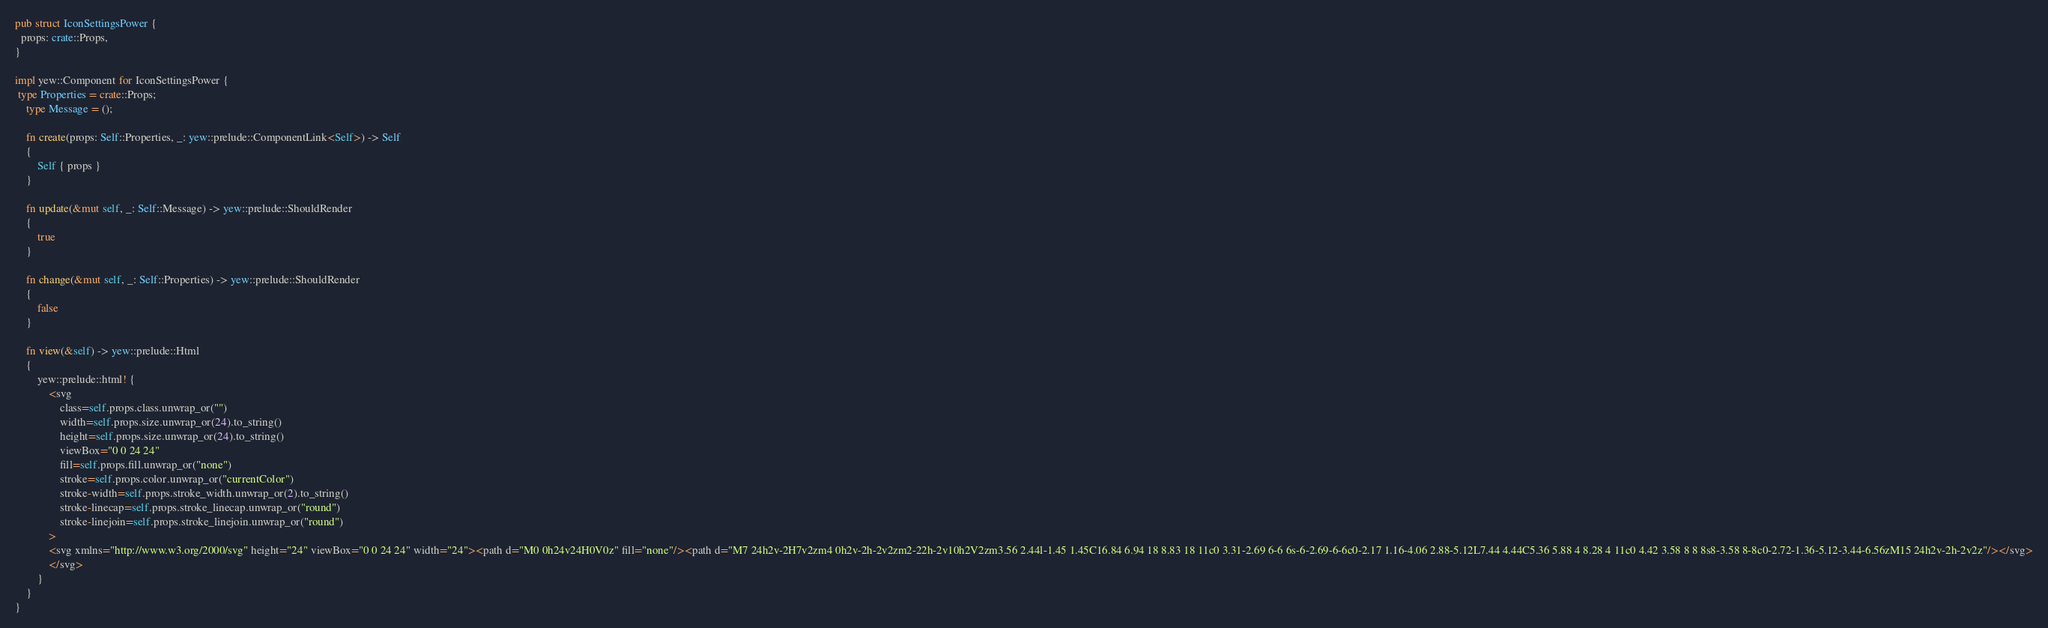<code> <loc_0><loc_0><loc_500><loc_500><_Rust_>
pub struct IconSettingsPower {
  props: crate::Props,
}

impl yew::Component for IconSettingsPower {
 type Properties = crate::Props;
    type Message = ();

    fn create(props: Self::Properties, _: yew::prelude::ComponentLink<Self>) -> Self
    {
        Self { props }
    }

    fn update(&mut self, _: Self::Message) -> yew::prelude::ShouldRender
    {
        true
    }

    fn change(&mut self, _: Self::Properties) -> yew::prelude::ShouldRender
    {
        false
    }

    fn view(&self) -> yew::prelude::Html
    {
        yew::prelude::html! {
            <svg
                class=self.props.class.unwrap_or("")
                width=self.props.size.unwrap_or(24).to_string()
                height=self.props.size.unwrap_or(24).to_string()
                viewBox="0 0 24 24"
                fill=self.props.fill.unwrap_or("none")
                stroke=self.props.color.unwrap_or("currentColor")
                stroke-width=self.props.stroke_width.unwrap_or(2).to_string()
                stroke-linecap=self.props.stroke_linecap.unwrap_or("round")
                stroke-linejoin=self.props.stroke_linejoin.unwrap_or("round")
            >
            <svg xmlns="http://www.w3.org/2000/svg" height="24" viewBox="0 0 24 24" width="24"><path d="M0 0h24v24H0V0z" fill="none"/><path d="M7 24h2v-2H7v2zm4 0h2v-2h-2v2zm2-22h-2v10h2V2zm3.56 2.44l-1.45 1.45C16.84 6.94 18 8.83 18 11c0 3.31-2.69 6-6 6s-6-2.69-6-6c0-2.17 1.16-4.06 2.88-5.12L7.44 4.44C5.36 5.88 4 8.28 4 11c0 4.42 3.58 8 8 8s8-3.58 8-8c0-2.72-1.36-5.12-3.44-6.56zM15 24h2v-2h-2v2z"/></svg>
            </svg>
        }
    }
}


</code> 